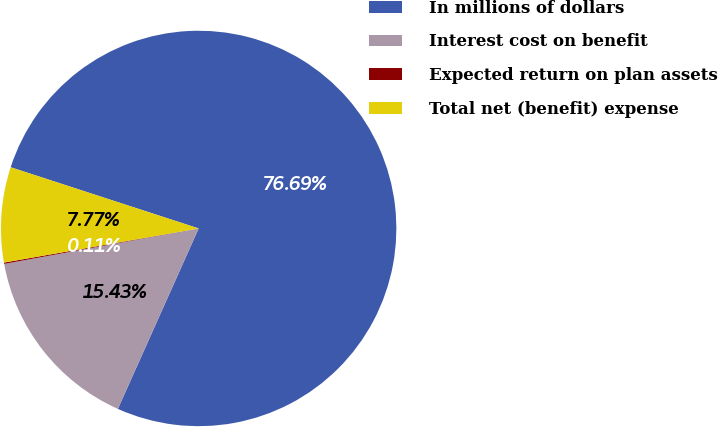Convert chart to OTSL. <chart><loc_0><loc_0><loc_500><loc_500><pie_chart><fcel>In millions of dollars<fcel>Interest cost on benefit<fcel>Expected return on plan assets<fcel>Total net (benefit) expense<nl><fcel>76.69%<fcel>15.43%<fcel>0.11%<fcel>7.77%<nl></chart> 